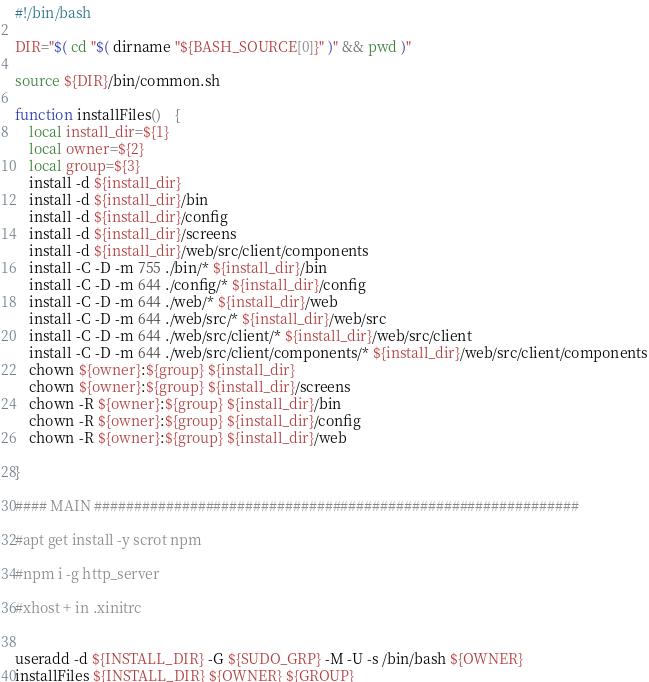<code> <loc_0><loc_0><loc_500><loc_500><_Bash_>#!/bin/bash

DIR="$( cd "$( dirname "${BASH_SOURCE[0]}" )" && pwd )"

source ${DIR}/bin/common.sh

function installFiles()	{
	local install_dir=${1}
	local owner=${2}
	local group=${3}
	install -d ${install_dir}
	install -d ${install_dir}/bin
	install -d ${install_dir}/config
	install -d ${install_dir}/screens
	install -d ${install_dir}/web/src/client/components
	install -C -D -m 755 ./bin/* ${install_dir}/bin
	install -C -D -m 644 ./config/* ${install_dir}/config
	install -C -D -m 644 ./web/* ${install_dir}/web
	install -C -D -m 644 ./web/src/* ${install_dir}/web/src
	install -C -D -m 644 ./web/src/client/* ${install_dir}/web/src/client
	install -C -D -m 644 ./web/src/client/components/* ${install_dir}/web/src/client/components
	chown ${owner}:${group} ${install_dir}
	chown ${owner}:${group} ${install_dir}/screens
	chown -R ${owner}:${group} ${install_dir}/bin
	chown -R ${owner}:${group} ${install_dir}/config
	chown -R ${owner}:${group} ${install_dir}/web

}

#### MAIN #############################################################

#apt get install -y scrot npm

#npm i -g http_server

#xhost + in .xinitrc


useradd -d ${INSTALL_DIR} -G ${SUDO_GRP} -M -U -s /bin/bash ${OWNER} 
installFiles ${INSTALL_DIR} ${OWNER} ${GROUP}

</code> 